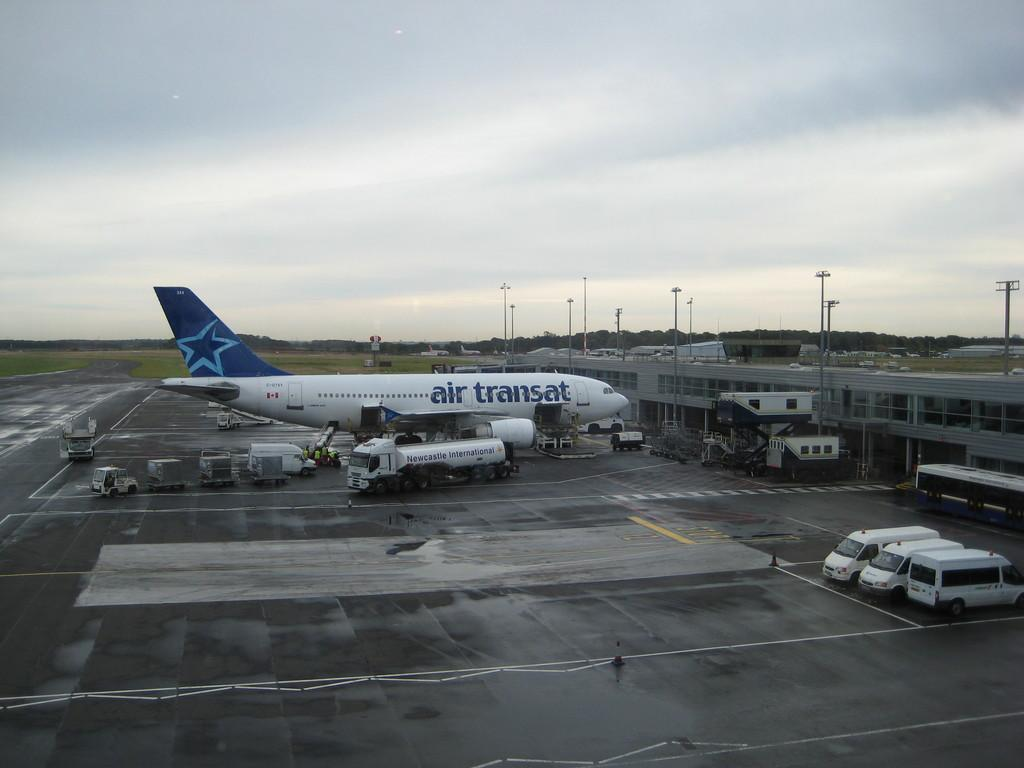What is the main subject of the image? The main subject of the image is an airplane on the ground. What else can be seen near the airplane? There are vehicles beside the airplane. What structures are present in the image? There are poles and a building in the image. What can be seen in the distance in the image? There are trees visible in the background of the image. What question is the airplane asking in the image? There is no indication in the image that the airplane is asking a question. Airplanes do not have the ability to ask questions. 